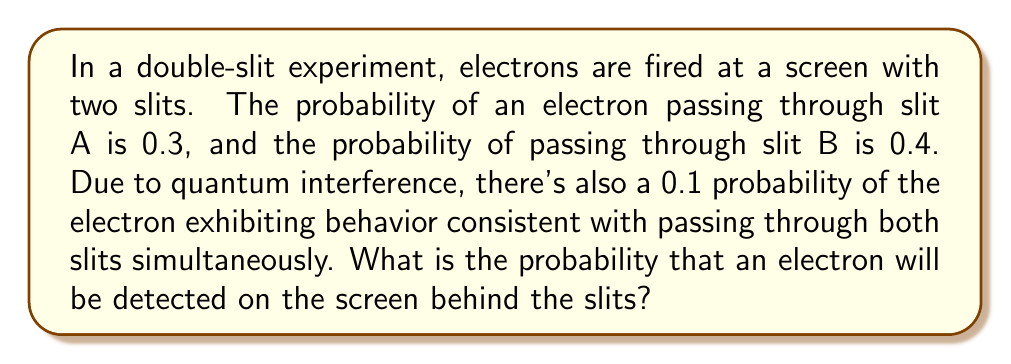Can you answer this question? To solve this problem, we need to consider the fundamental principles of quantum mechanics and probability theory. Let's break it down step-by-step:

1) First, let's define our events:
   A: Electron passes through slit A
   B: Electron passes through slit B
   C: Electron exhibits behavior consistent with passing through both slits

2) We're given the following probabilities:
   $P(A) = 0.3$
   $P(B) = 0.4$
   $P(C) = 0.1$

3) In classical probability, we would simply add these probabilities. However, in quantum mechanics, we need to consider the possibility of superposition and interference.

4) The probability of the electron being detected on the screen is the sum of the probabilities of all possible outcomes:

   $P(\text{detected}) = P(A) + P(B) + P(C)$

5) This is because these events are mutually exclusive in terms of detection outcomes. An electron can't be detected as having gone through only slit A and only slit B at the same time.

6) Substituting the values:

   $P(\text{detected}) = 0.3 + 0.4 + 0.1 = 0.8$

7) It's important to note that this result implies there's a 0.2 (or 20%) probability that the electron is not detected at all. This could be due to various factors such as the electron being absorbed by the slit apparatus or other quantum effects.

8) This example illustrates the non-classical nature of quantum probabilities. The fact that there's a non-zero probability for the electron to exhibit behavior consistent with passing through both slits simultaneously (event C) is a key feature of quantum mechanics, demonstrating wave-particle duality and superposition.
Answer: The probability that an electron will be detected on the screen is 0.8 or 80%. 